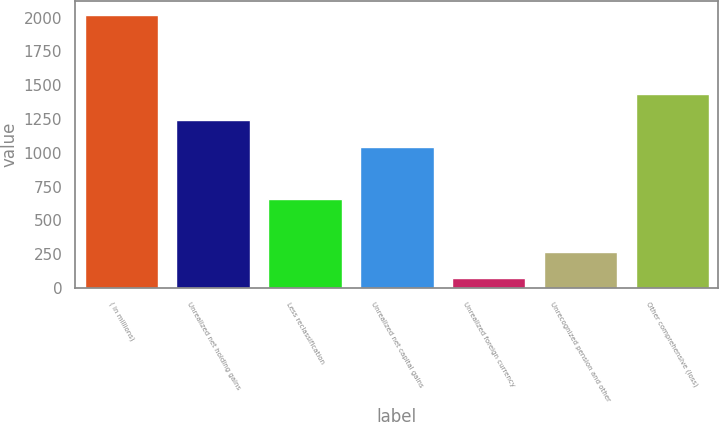Convert chart. <chart><loc_0><loc_0><loc_500><loc_500><bar_chart><fcel>( in millions)<fcel>Unrealized net holding gains<fcel>Less reclassification<fcel>Unrealized net capital gains<fcel>Unrealized foreign currency<fcel>Unrecognized pension and other<fcel>Other comprehensive (loss)<nl><fcel>2018<fcel>1238.8<fcel>654.4<fcel>1044<fcel>70<fcel>264.8<fcel>1433.6<nl></chart> 